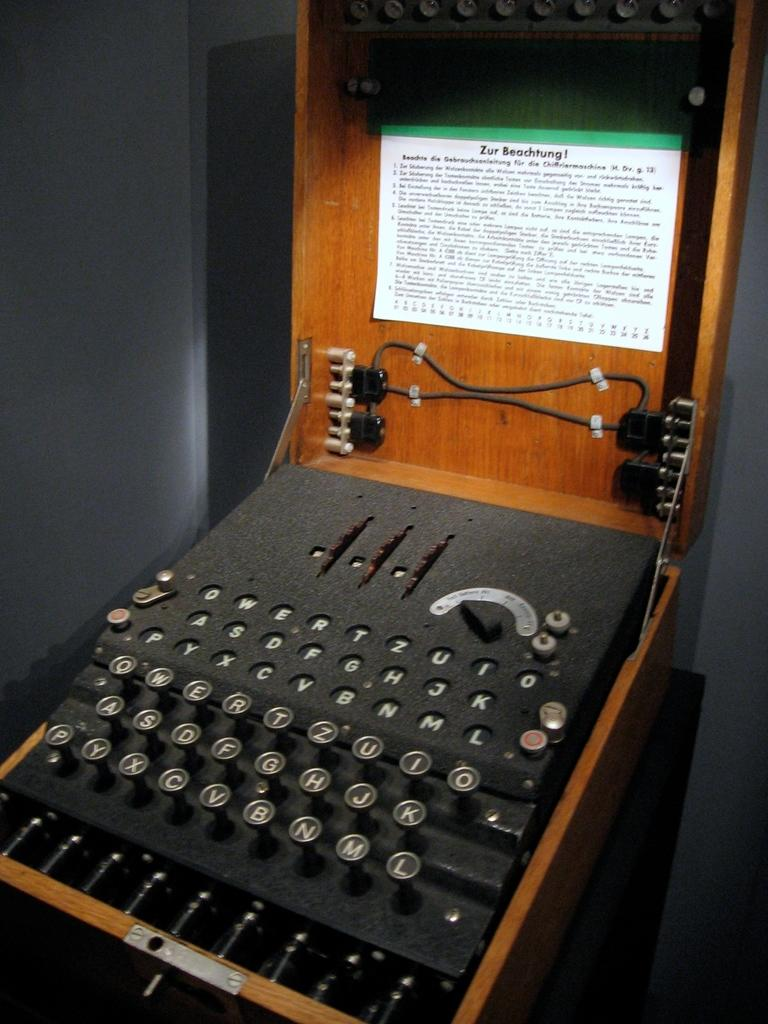Provide a one-sentence caption for the provided image. A very old looking typewriter with an instruction manual that starts with the phrase Zur Beachtung. 